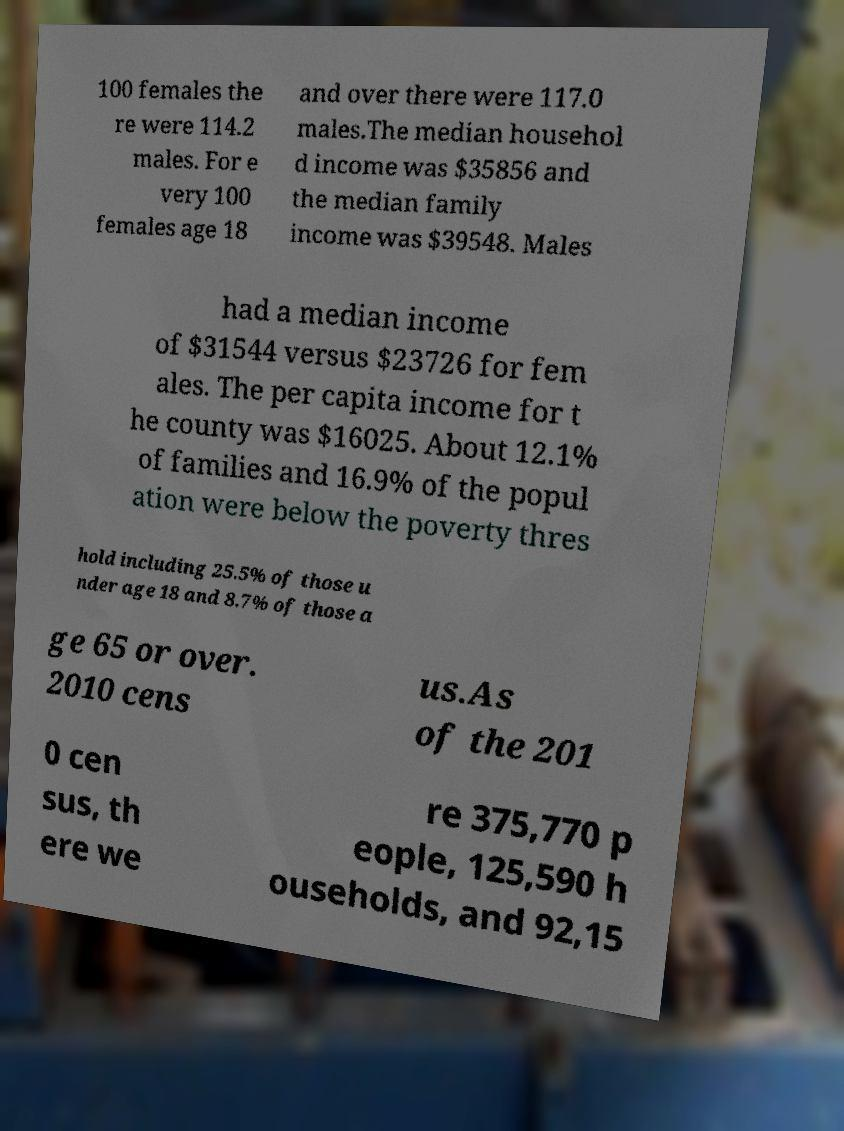Can you read and provide the text displayed in the image?This photo seems to have some interesting text. Can you extract and type it out for me? 100 females the re were 114.2 males. For e very 100 females age 18 and over there were 117.0 males.The median househol d income was $35856 and the median family income was $39548. Males had a median income of $31544 versus $23726 for fem ales. The per capita income for t he county was $16025. About 12.1% of families and 16.9% of the popul ation were below the poverty thres hold including 25.5% of those u nder age 18 and 8.7% of those a ge 65 or over. 2010 cens us.As of the 201 0 cen sus, th ere we re 375,770 p eople, 125,590 h ouseholds, and 92,15 